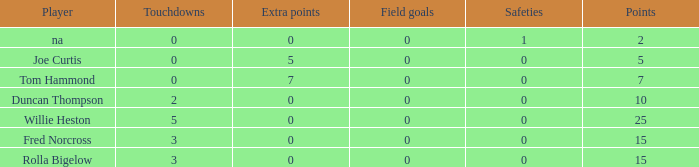How many Touchdowns have a Player of rolla bigelow, and an Extra points smaller than 0? None. 